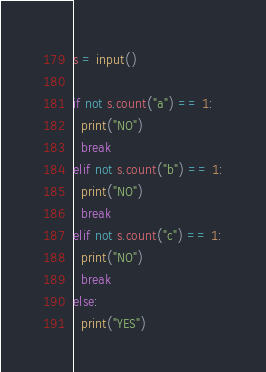<code> <loc_0><loc_0><loc_500><loc_500><_Python_>s = input()

if not s.count("a") == 1:
  print("NO")
  break
elif not s.count("b") == 1:
  print("NO")
  break
elif not s.count("c") == 1:
  print("NO")
  break
else:
  print("YES")</code> 